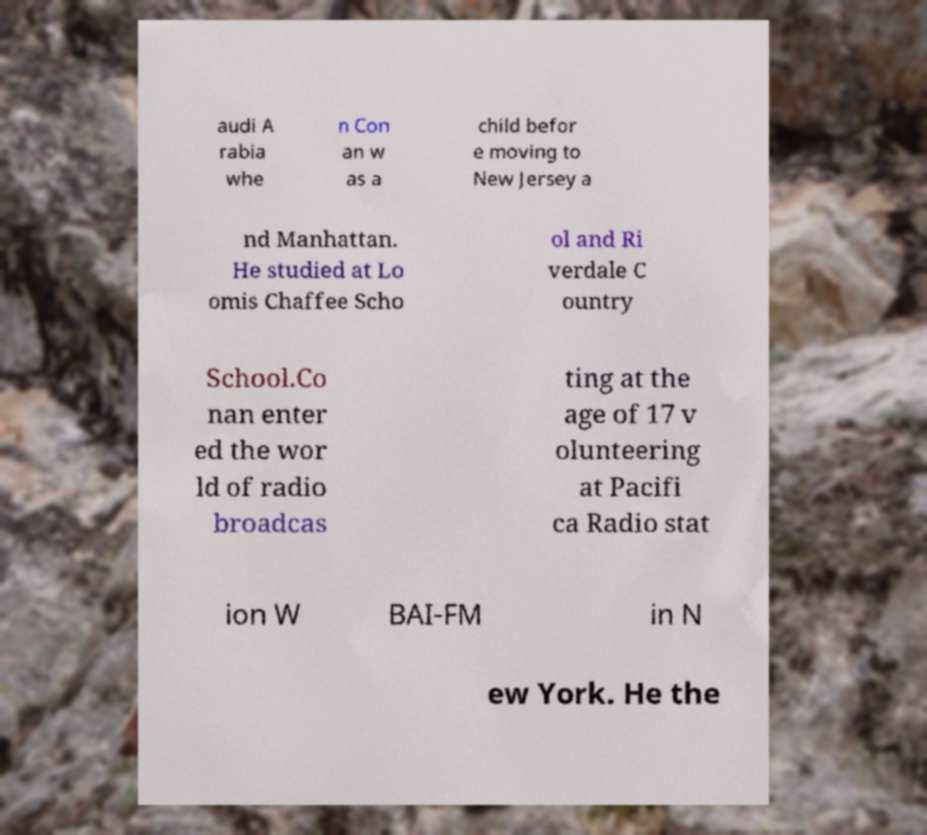Could you extract and type out the text from this image? audi A rabia whe n Con an w as a child befor e moving to New Jersey a nd Manhattan. He studied at Lo omis Chaffee Scho ol and Ri verdale C ountry School.Co nan enter ed the wor ld of radio broadcas ting at the age of 17 v olunteering at Pacifi ca Radio stat ion W BAI-FM in N ew York. He the 